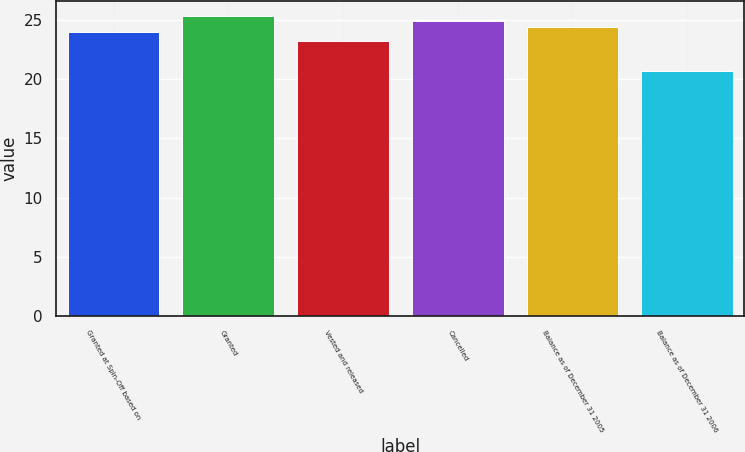Convert chart. <chart><loc_0><loc_0><loc_500><loc_500><bar_chart><fcel>Granted at Spin-Off based on<fcel>Granted<fcel>Vested and released<fcel>Cancelled<fcel>Balance as of December 31 2005<fcel>Balance as of December 31 2006<nl><fcel>23.97<fcel>25.35<fcel>23.19<fcel>24.89<fcel>24.43<fcel>20.72<nl></chart> 